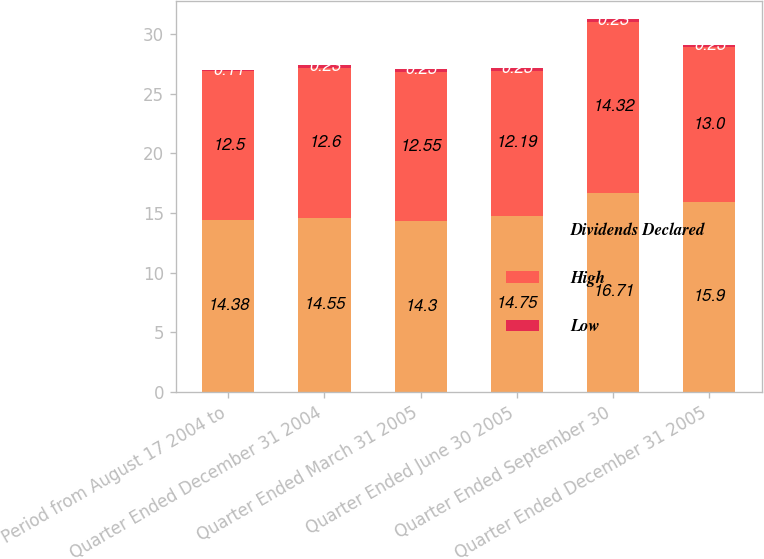<chart> <loc_0><loc_0><loc_500><loc_500><stacked_bar_chart><ecel><fcel>Period from August 17 2004 to<fcel>Quarter Ended December 31 2004<fcel>Quarter Ended March 31 2005<fcel>Quarter Ended June 30 2005<fcel>Quarter Ended September 30<fcel>Quarter Ended December 31 2005<nl><fcel>Dividends Declared<fcel>14.38<fcel>14.55<fcel>14.3<fcel>14.75<fcel>16.71<fcel>15.9<nl><fcel>High<fcel>12.5<fcel>12.6<fcel>12.55<fcel>12.19<fcel>14.32<fcel>13<nl><fcel>Low<fcel>0.11<fcel>0.23<fcel>0.23<fcel>0.23<fcel>0.23<fcel>0.23<nl></chart> 